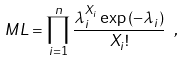<formula> <loc_0><loc_0><loc_500><loc_500>M L = \prod _ { i = 1 } ^ { n } \frac { \lambda _ { i } ^ { X _ { i } } \exp { ( - \lambda _ { i } ) } } { X _ { i } ! } \ ,</formula> 